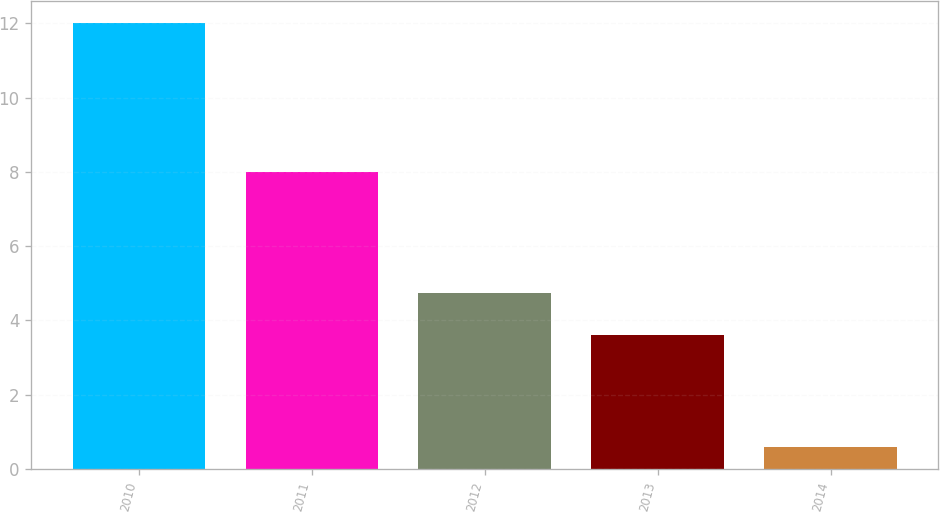Convert chart to OTSL. <chart><loc_0><loc_0><loc_500><loc_500><bar_chart><fcel>2010<fcel>2011<fcel>2012<fcel>2013<fcel>2014<nl><fcel>12<fcel>8<fcel>4.74<fcel>3.6<fcel>0.6<nl></chart> 